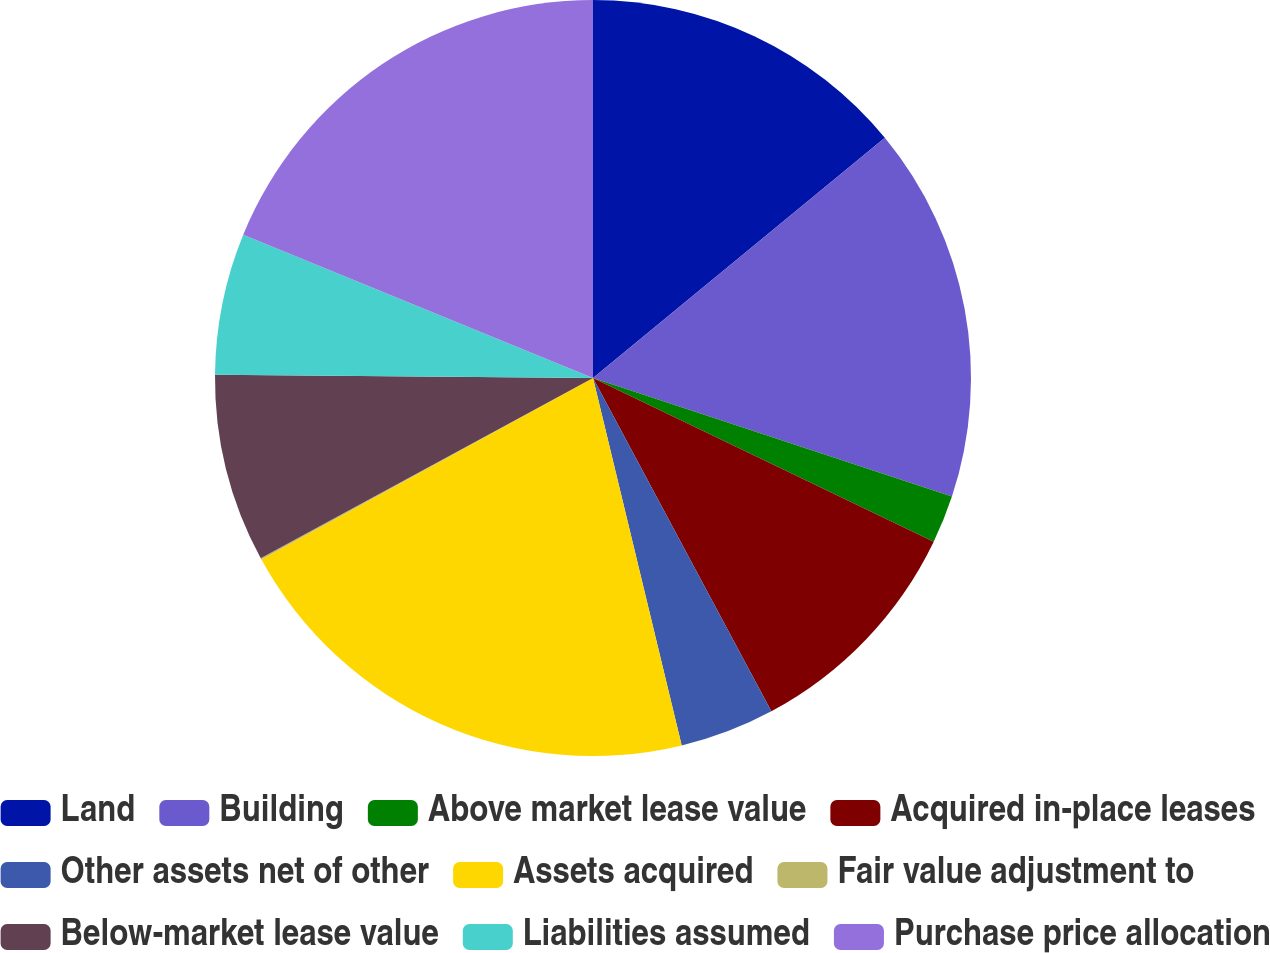Convert chart. <chart><loc_0><loc_0><loc_500><loc_500><pie_chart><fcel>Land<fcel>Building<fcel>Above market lease value<fcel>Acquired in-place leases<fcel>Other assets net of other<fcel>Assets acquired<fcel>Fair value adjustment to<fcel>Below-market lease value<fcel>Liabilities assumed<fcel>Purchase price allocation<nl><fcel>14.04%<fcel>16.04%<fcel>2.05%<fcel>10.05%<fcel>4.05%<fcel>20.8%<fcel>0.06%<fcel>8.05%<fcel>6.05%<fcel>18.81%<nl></chart> 